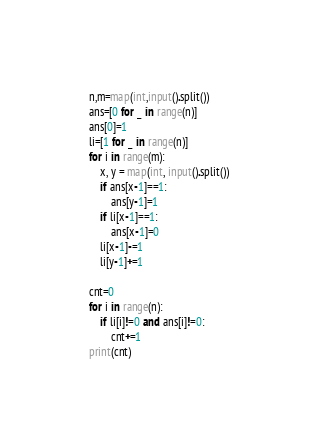<code> <loc_0><loc_0><loc_500><loc_500><_Python_>n,m=map(int,input().split())
ans=[0 for _ in range(n)]
ans[0]=1
li=[1 for _ in range(n)]
for i in range(m):
    x, y = map(int, input().split())
    if ans[x-1]==1:
        ans[y-1]=1
    if li[x-1]==1:
        ans[x-1]=0
    li[x-1]-=1
    li[y-1]+=1
  
cnt=0
for i in range(n):
    if li[i]!=0 and ans[i]!=0:
        cnt+=1
print(cnt)</code> 